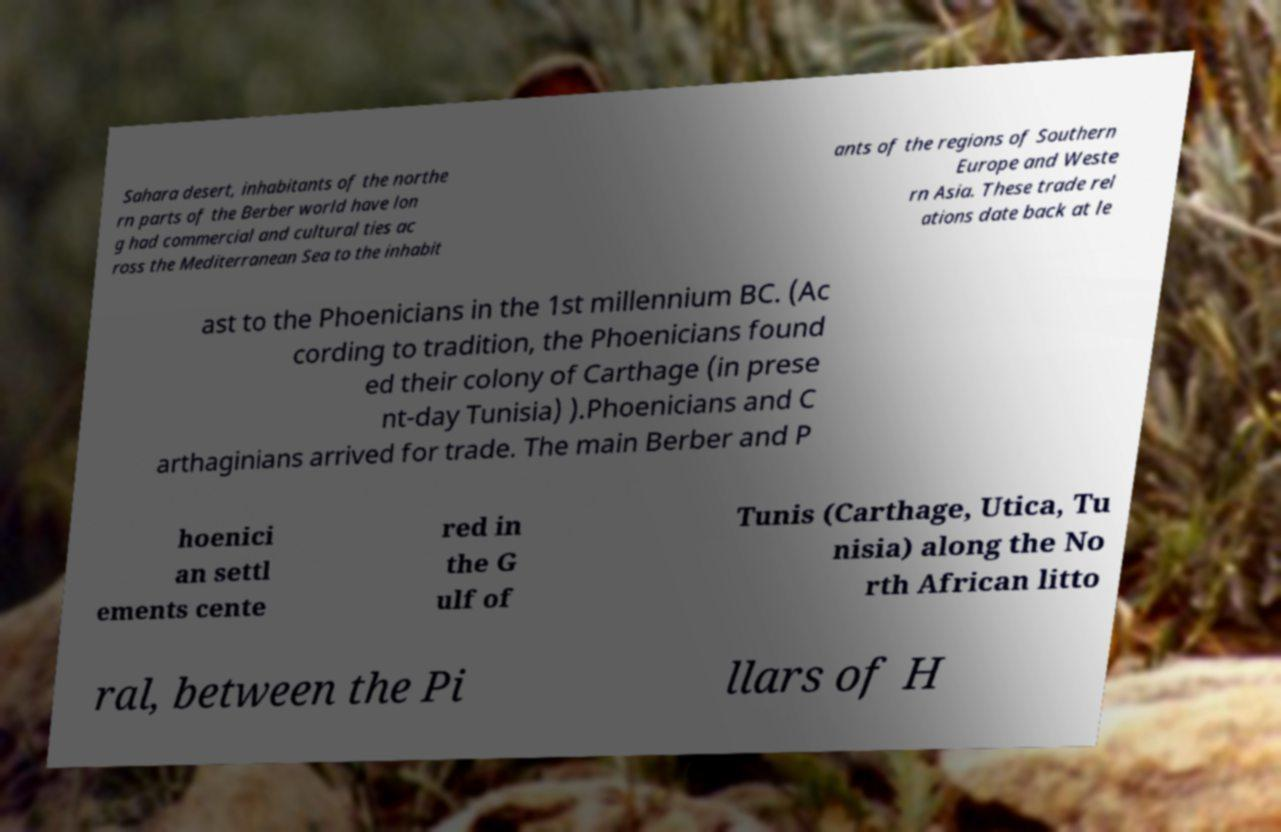Can you accurately transcribe the text from the provided image for me? Sahara desert, inhabitants of the northe rn parts of the Berber world have lon g had commercial and cultural ties ac ross the Mediterranean Sea to the inhabit ants of the regions of Southern Europe and Weste rn Asia. These trade rel ations date back at le ast to the Phoenicians in the 1st millennium BC. (Ac cording to tradition, the Phoenicians found ed their colony of Carthage (in prese nt-day Tunisia) ).Phoenicians and C arthaginians arrived for trade. The main Berber and P hoenici an settl ements cente red in the G ulf of Tunis (Carthage, Utica, Tu nisia) along the No rth African litto ral, between the Pi llars of H 